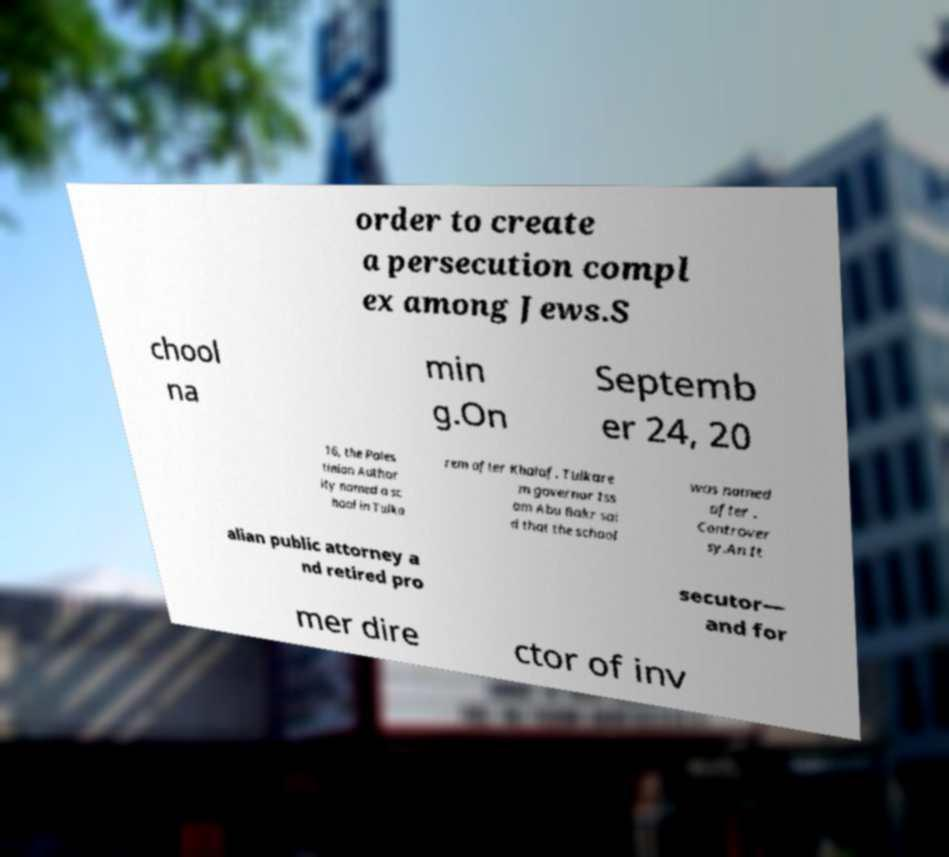For documentation purposes, I need the text within this image transcribed. Could you provide that? order to create a persecution compl ex among Jews.S chool na min g.On Septemb er 24, 20 16, the Pales tinian Author ity named a sc hool in Tulka rem after Khalaf. Tulkare m governor Iss am Abu Bakr sai d that the school was named after . Controver sy.An It alian public attorney a nd retired pro secutor— and for mer dire ctor of inv 